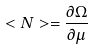Convert formula to latex. <formula><loc_0><loc_0><loc_500><loc_500>< N > = \frac { \partial \Omega } { \partial \mu }</formula> 